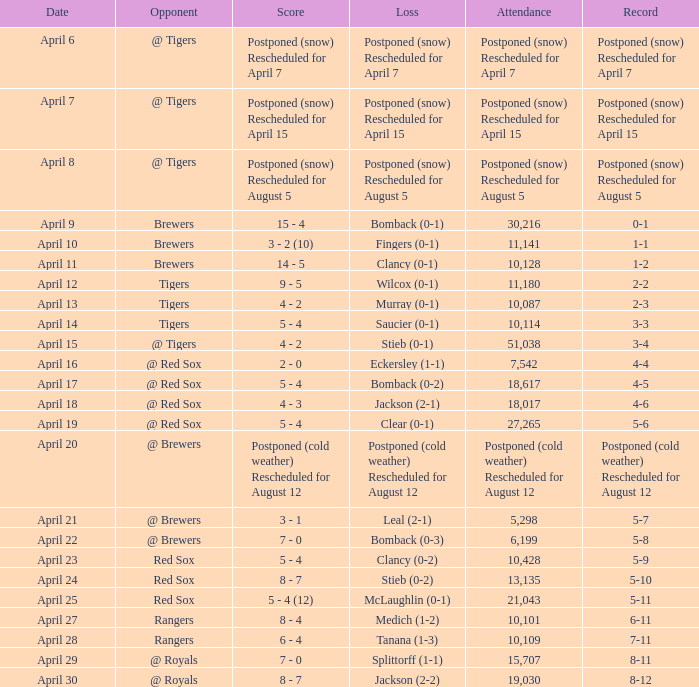Which record is dated April 8? Postponed (snow) Rescheduled for August 5. 